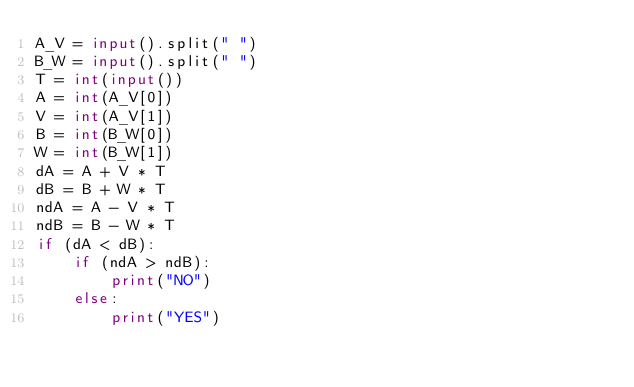<code> <loc_0><loc_0><loc_500><loc_500><_Python_>A_V = input().split(" ")
B_W = input().split(" ")
T = int(input())
A = int(A_V[0])
V = int(A_V[1])
B = int(B_W[0])
W = int(B_W[1])
dA = A + V * T
dB = B + W * T
ndA = A - V * T
ndB = B - W * T
if (dA < dB):
    if (ndA > ndB):
        print("NO")
    else:
        print("YES")</code> 